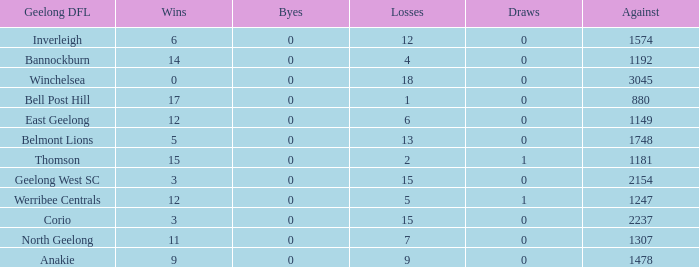What is the total number of losses where the byes were greater than 0? 0.0. 